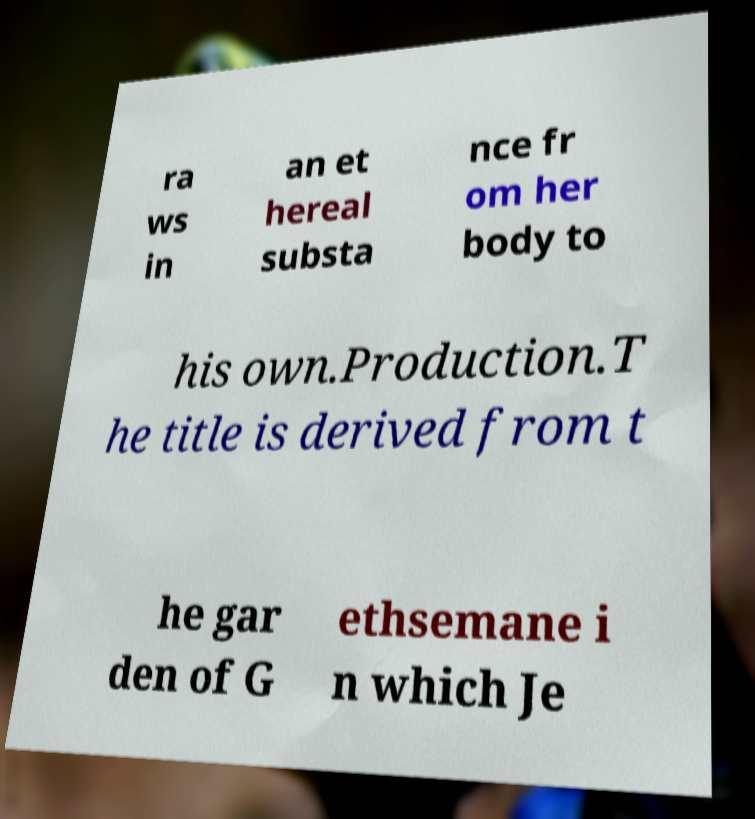Could you assist in decoding the text presented in this image and type it out clearly? ra ws in an et hereal substa nce fr om her body to his own.Production.T he title is derived from t he gar den of G ethsemane i n which Je 